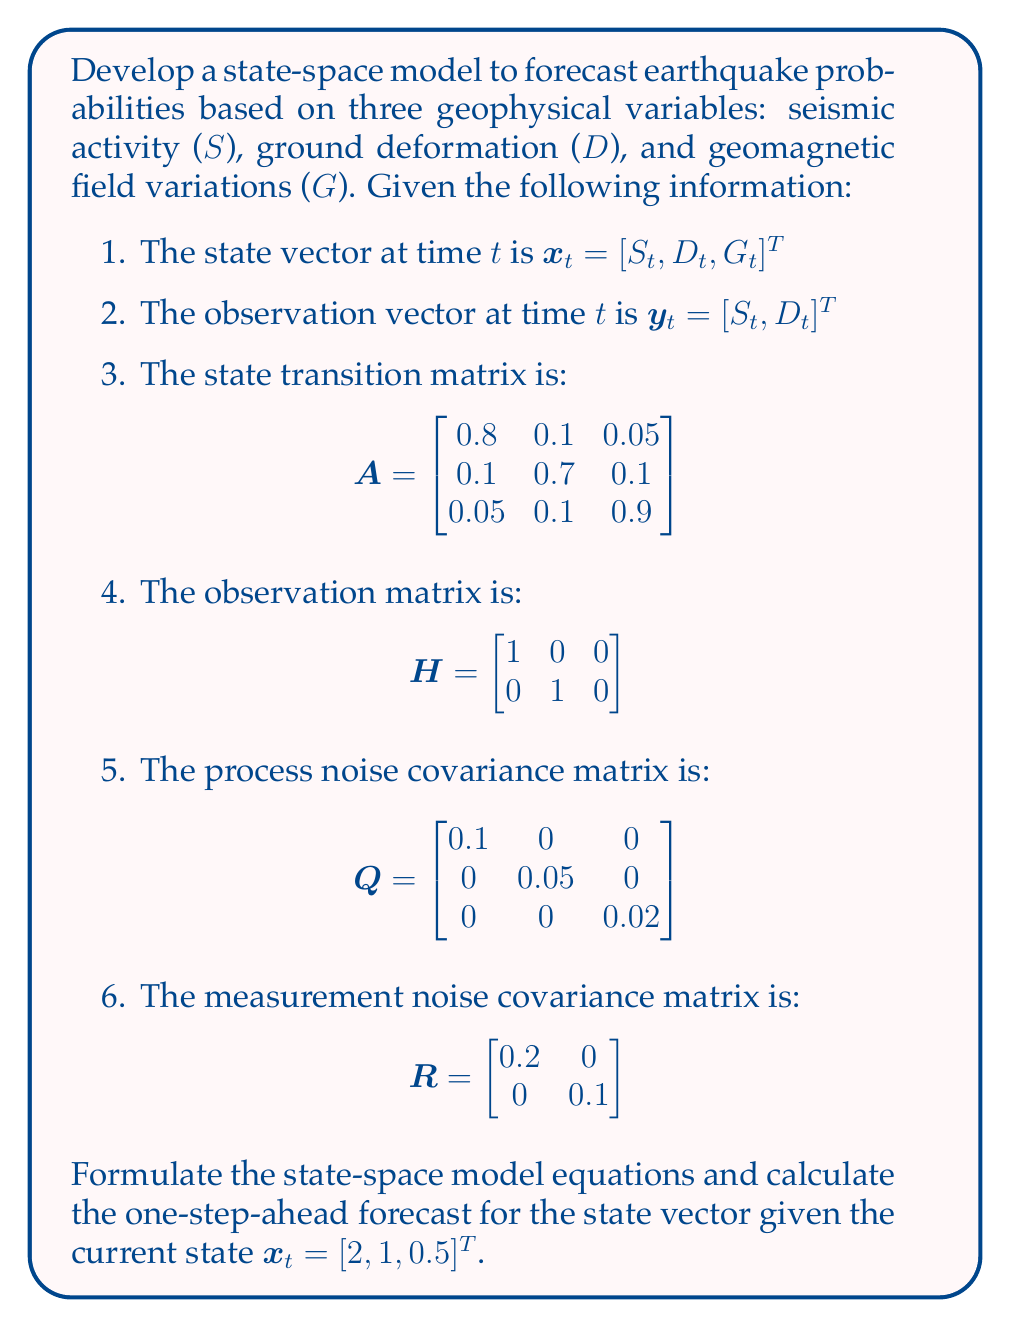Solve this math problem. To develop the state-space model and calculate the one-step-ahead forecast, we'll follow these steps:

1. Formulate the state-space model equations:
   The state-space model consists of two equations:

   State equation: $x_{t+1} = Ax_t + w_t$
   Observation equation: $y_t = Hx_t + v_t$

   Where:
   - $x_t$ is the state vector at time t
   - $y_t$ is the observation vector at time t
   - $A$ is the state transition matrix
   - $H$ is the observation matrix
   - $w_t$ is the process noise with covariance Q
   - $v_t$ is the measurement noise with covariance R

2. Calculate the one-step-ahead forecast:
   The one-step-ahead forecast for the state vector is given by:

   $\hat{x}_{t+1|t} = Ax_t$

   We'll use the given current state $x_t = [2, 1, 0.5]^T$ and the state transition matrix A to calculate the forecast.

   $$\hat{x}_{t+1|t} = \begin{bmatrix}
   0.8 & 0.1 & 0.05 \\
   0.1 & 0.7 & 0.1 \\
   0.05 & 0.1 & 0.9
   \end{bmatrix} \begin{bmatrix}
   2 \\
   1 \\
   0.5
   \end{bmatrix}$$

   $$\hat{x}_{t+1|t} = \begin{bmatrix}
   (0.8 \times 2) + (0.1 \times 1) + (0.05 \times 0.5) \\
   (0.1 \times 2) + (0.7 \times 1) + (0.1 \times 0.5) \\
   (0.05 \times 2) + (0.1 \times 1) + (0.9 \times 0.5)
   \end{bmatrix}$$

   $$\hat{x}_{t+1|t} = \begin{bmatrix}
   1.725 \\
   0.95 \\
   0.55
   \end{bmatrix}$$

This one-step-ahead forecast represents the predicted values for seismic activity (S), ground deformation (D), and geomagnetic field variations (G) in the next time step, based on the current state and the state transition matrix.
Answer: The state-space model equations are:

State equation: $x_{t+1} = Ax_t + w_t$
Observation equation: $y_t = Hx_t + v_t$

The one-step-ahead forecast for the state vector is:

$$\hat{x}_{t+1|t} = \begin{bmatrix}
1.725 \\
0.95 \\
0.55
\end{bmatrix}$$ 